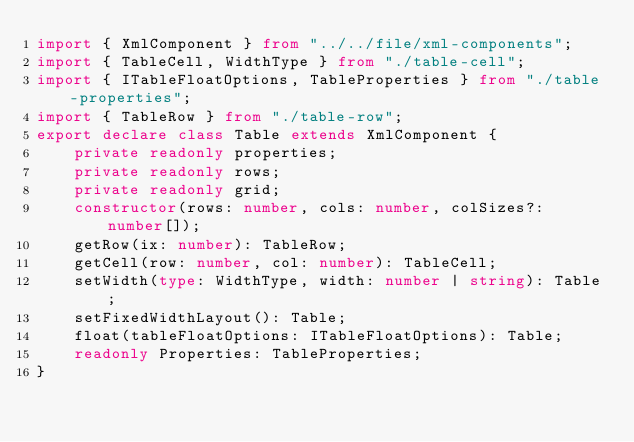<code> <loc_0><loc_0><loc_500><loc_500><_TypeScript_>import { XmlComponent } from "../../file/xml-components";
import { TableCell, WidthType } from "./table-cell";
import { ITableFloatOptions, TableProperties } from "./table-properties";
import { TableRow } from "./table-row";
export declare class Table extends XmlComponent {
    private readonly properties;
    private readonly rows;
    private readonly grid;
    constructor(rows: number, cols: number, colSizes?: number[]);
    getRow(ix: number): TableRow;
    getCell(row: number, col: number): TableCell;
    setWidth(type: WidthType, width: number | string): Table;
    setFixedWidthLayout(): Table;
    float(tableFloatOptions: ITableFloatOptions): Table;
    readonly Properties: TableProperties;
}
</code> 